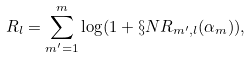<formula> <loc_0><loc_0><loc_500><loc_500>R _ { l } = \sum _ { m ^ { \prime } = 1 } ^ { m } \log ( 1 + \S N R _ { m ^ { \prime } , l } ( \alpha _ { m } ) ) ,</formula> 